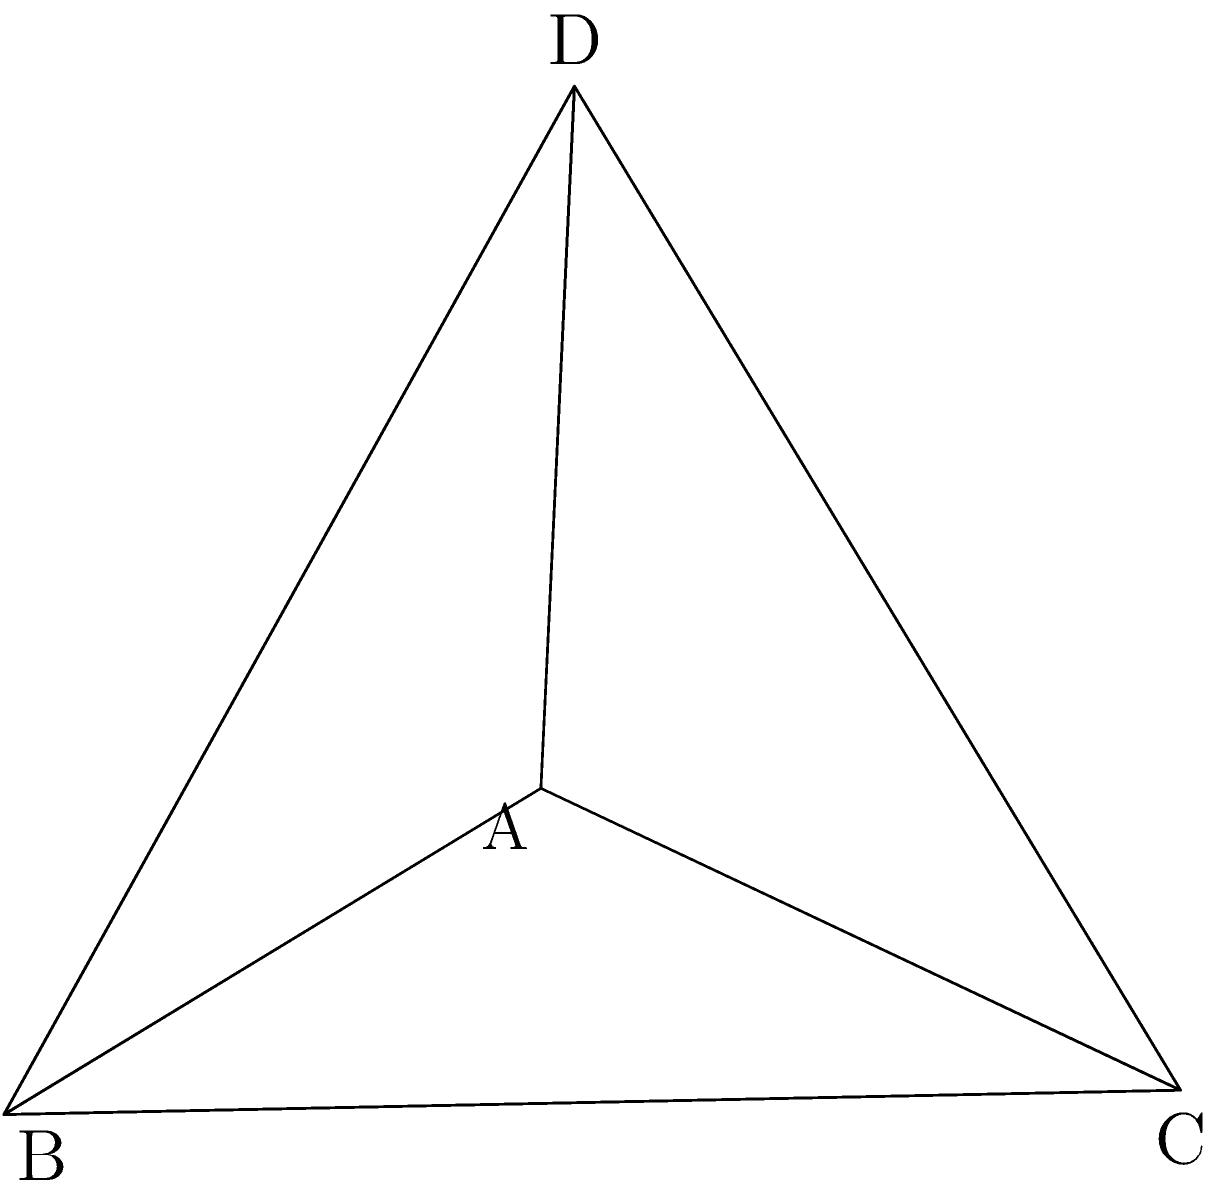As a Career Services worker, you're organizing a job fair booth with an octahedral display. The booth's central piece is a regular octahedron made of reflective material. If each edge of the octahedron measures 2 meters, what is the total surface area of the octahedron in square meters? Round your answer to two decimal places. Let's approach this step-by-step:

1) A regular octahedron consists of 8 congruent equilateral triangles.

2) The surface area of the octahedron is the sum of the areas of these 8 triangles.

3) To find the area of one triangular face, we need to use the formula for the area of an equilateral triangle:

   $A = \frac{\sqrt{3}}{4}a^2$

   where $a$ is the length of one side.

4) We're given that each edge is 2 meters, so $a = 2$.

5) Let's calculate the area of one face:

   $A = \frac{\sqrt{3}}{4}(2^2) = \sqrt{3}$ square meters

6) Since there are 8 identical faces, the total surface area is:

   $SA = 8 \times \sqrt{3}$ square meters

7) Calculating this:

   $SA = 8 \times \sqrt{3} \approx 13.8564$ square meters

8) Rounding to two decimal places:

   $SA \approx 13.86$ square meters
Answer: $13.86$ m² 